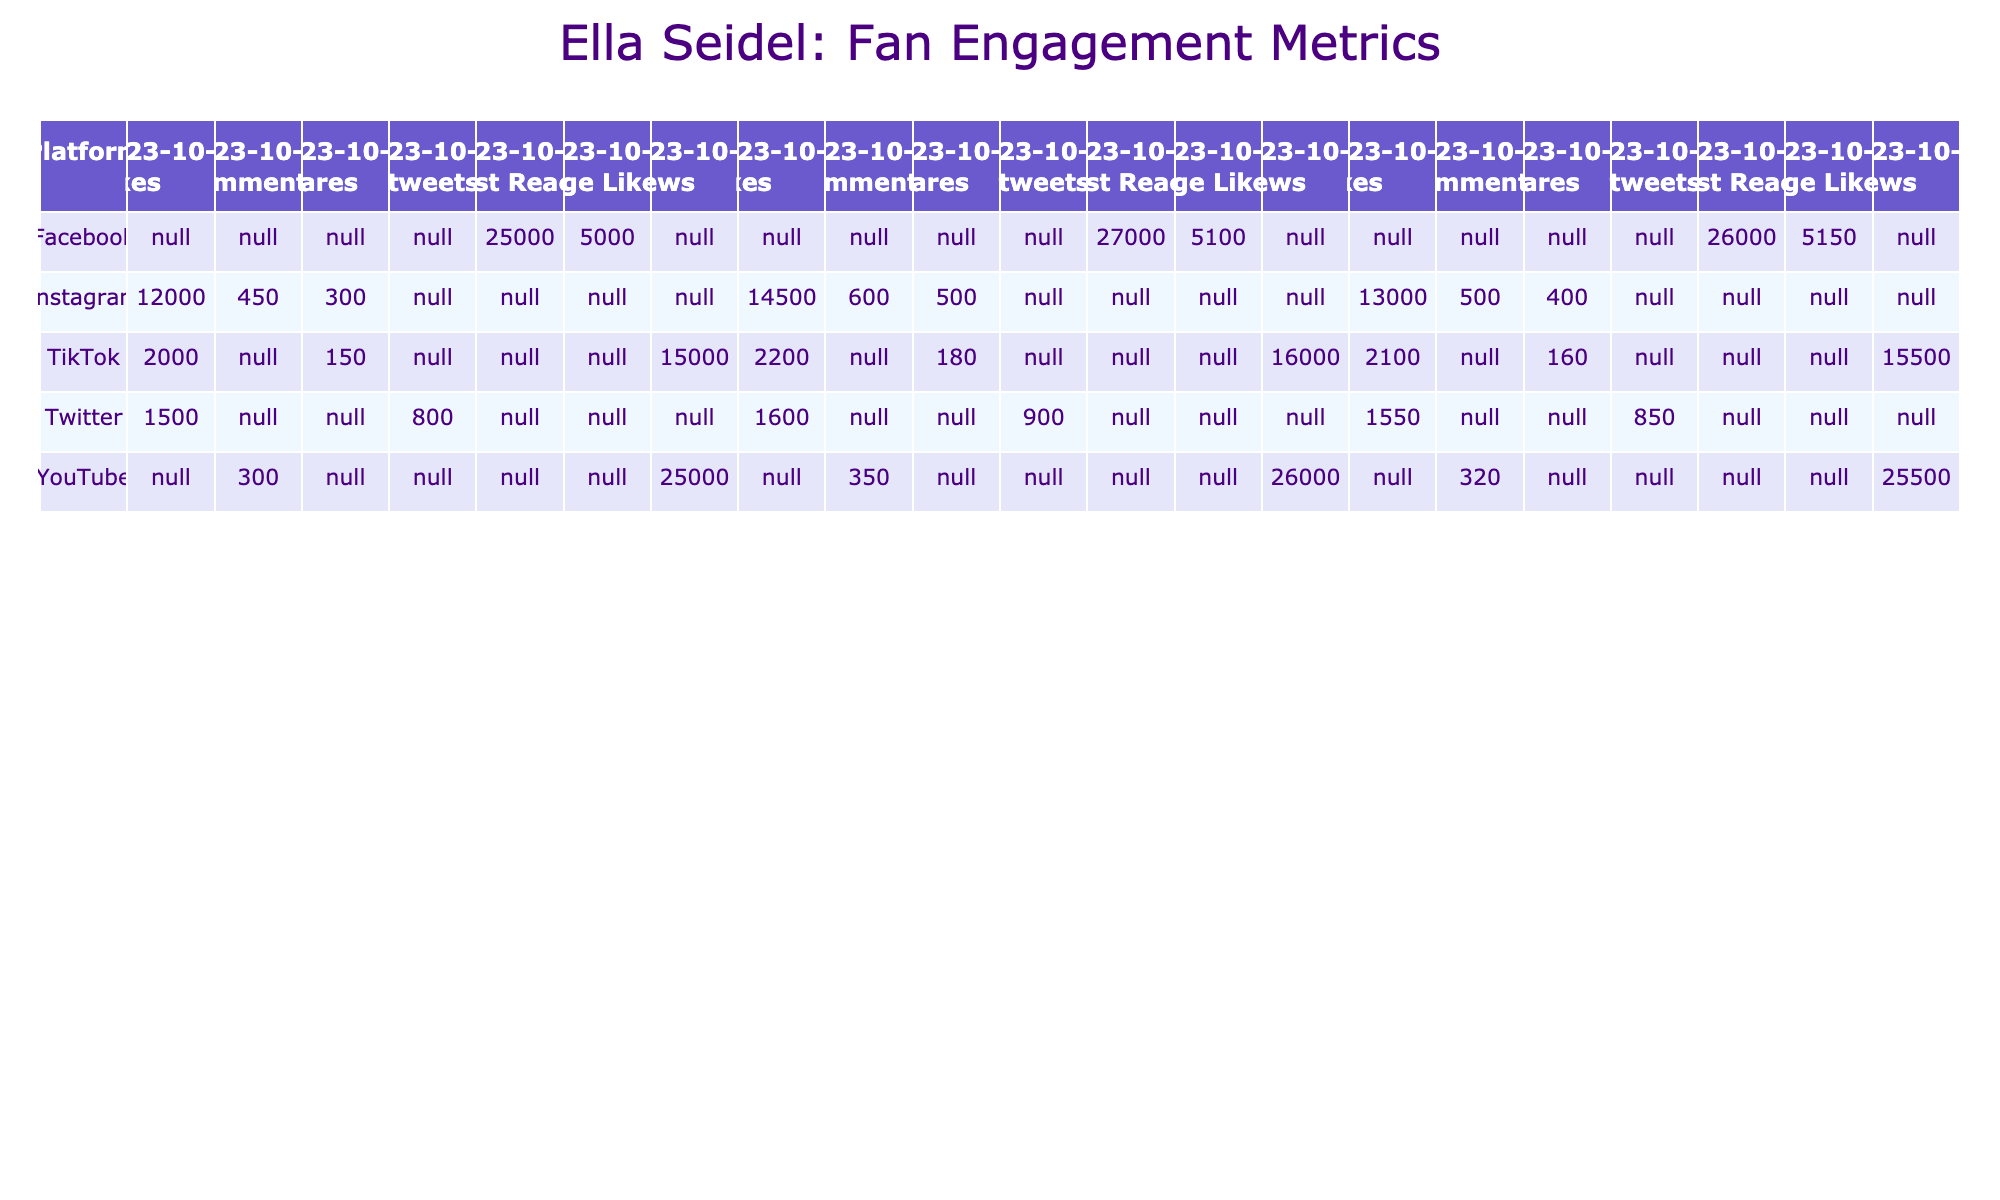What is the total number of Likes on Instagram for all recorded dates? To find this, we need to sum the Likes for each Instagram entry on the three dates: 12000 + 14500 + 13000 = 39500.
Answer: 39500 Which platform had the highest number of Page Likes on the last recorded date? The last recorded date is October 29, 2023. On that date, Facebook has 5150 Page Likes, which is higher than any other platform listed.
Answer: Facebook How many more Views on YouTube were recorded on October 15 compared to October 29? The Views on YouTube for October 15 are 26000, and for October 29 are 25500. The difference is 26000 - 25500 = 500.
Answer: 500 Did Ella Seidel have more Comments on TikTok or Instagram on October 29? On October 29, TikTok had 2100 Likes and Instagram had 500 Comments. Comparing these values shows Instagram had more Comments than TikTok on that date.
Answer: Yes What is the total engagement (sum of all metrics) for Facebook across all dates? The metrics for Facebook across the three dates are: Post Reach (25000, 27000, 26000) and Page Likes (5000, 5100, 5150). Summing these gives: (25000 + 27000 + 26000) + (5000 + 5100 + 5150) = 78000 + 15350 = 93350.
Answer: 93350 Which platform experienced a decrease in Post Reach from October 15 to October 29? The Post Reach for Facebook on October 15 is 27000 and on October 29 is 26000. This indicates a decrease.
Answer: Facebook What was the average number of Retweets on Twitter over the three recorded dates? The Retweets for Twitter are: 800, 900, and 850. The average is calculated as (800 + 900 + 850) / 3 = 2550 / 3 = 850.
Answer: 850 Is the number of Shares on TikTok greater than the number of Shares on Instagram on October 15? On October 15, TikTok had 180 Shares while Instagram had 500 Shares. Comparing these shows that Instagram had more Shares.
Answer: No What percentage increase in Likes on TikTok occurred from October 1 to October 15? Likes on TikTok were 2000 on October 15 and 1500 on October 1. The increase is (2000 - 1500) = 500, and the percentage increase is (500 / 1500) * 100 = 33.33%.
Answer: 33.33% Which platform had the lowest engagement in terms of Shares on October 29? On October 29, the Shares on TikTok were 160, Instagram had 400, and Twitter had 850. The lowest among these is TikTok with 160 Shares.
Answer: TikTok 